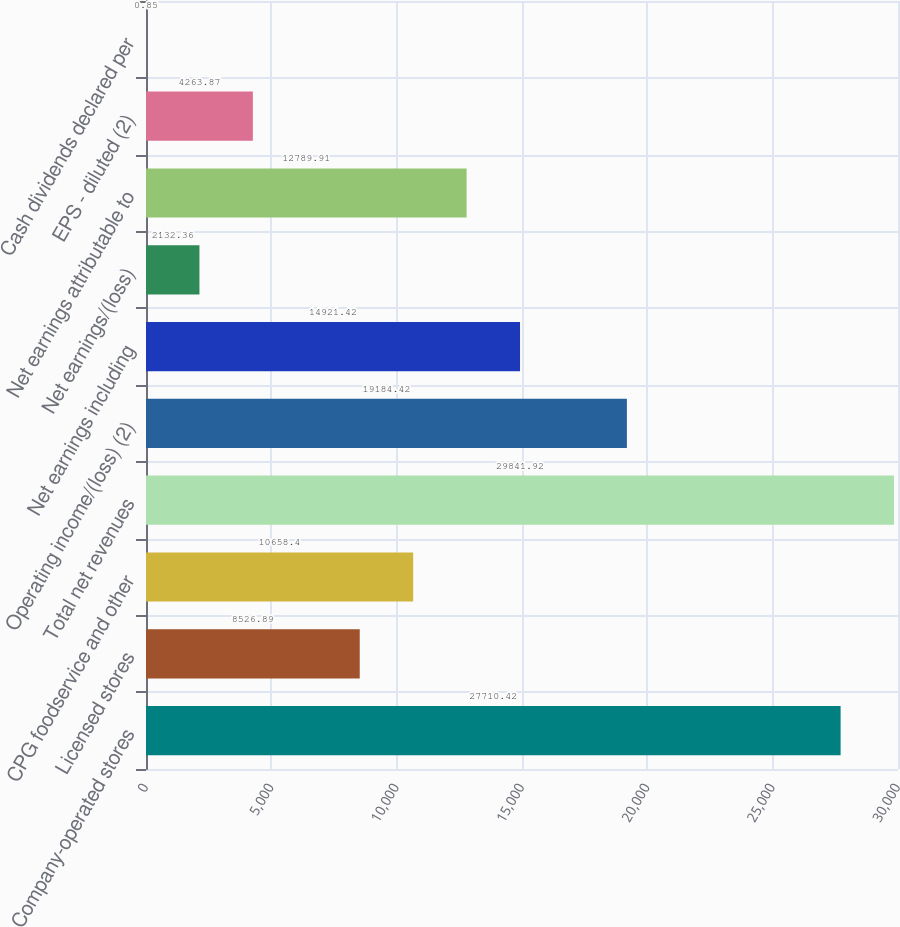Convert chart to OTSL. <chart><loc_0><loc_0><loc_500><loc_500><bar_chart><fcel>Company-operated stores<fcel>Licensed stores<fcel>CPG foodservice and other<fcel>Total net revenues<fcel>Operating income/(loss) (2)<fcel>Net earnings including<fcel>Net earnings/(loss)<fcel>Net earnings attributable to<fcel>EPS - diluted (2)<fcel>Cash dividends declared per<nl><fcel>27710.4<fcel>8526.89<fcel>10658.4<fcel>29841.9<fcel>19184.4<fcel>14921.4<fcel>2132.36<fcel>12789.9<fcel>4263.87<fcel>0.85<nl></chart> 